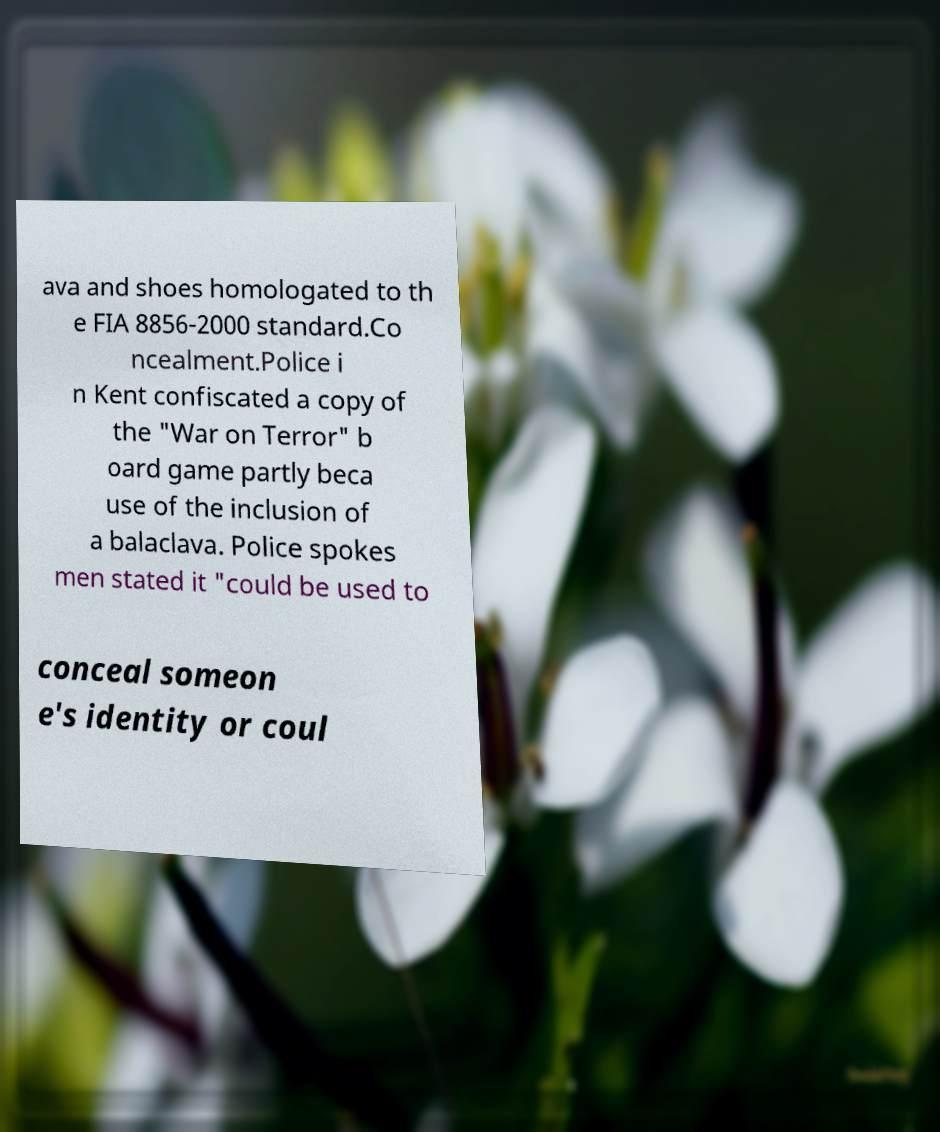Please identify and transcribe the text found in this image. ava and shoes homologated to th e FIA 8856-2000 standard.Co ncealment.Police i n Kent confiscated a copy of the "War on Terror" b oard game partly beca use of the inclusion of a balaclava. Police spokes men stated it "could be used to conceal someon e's identity or coul 